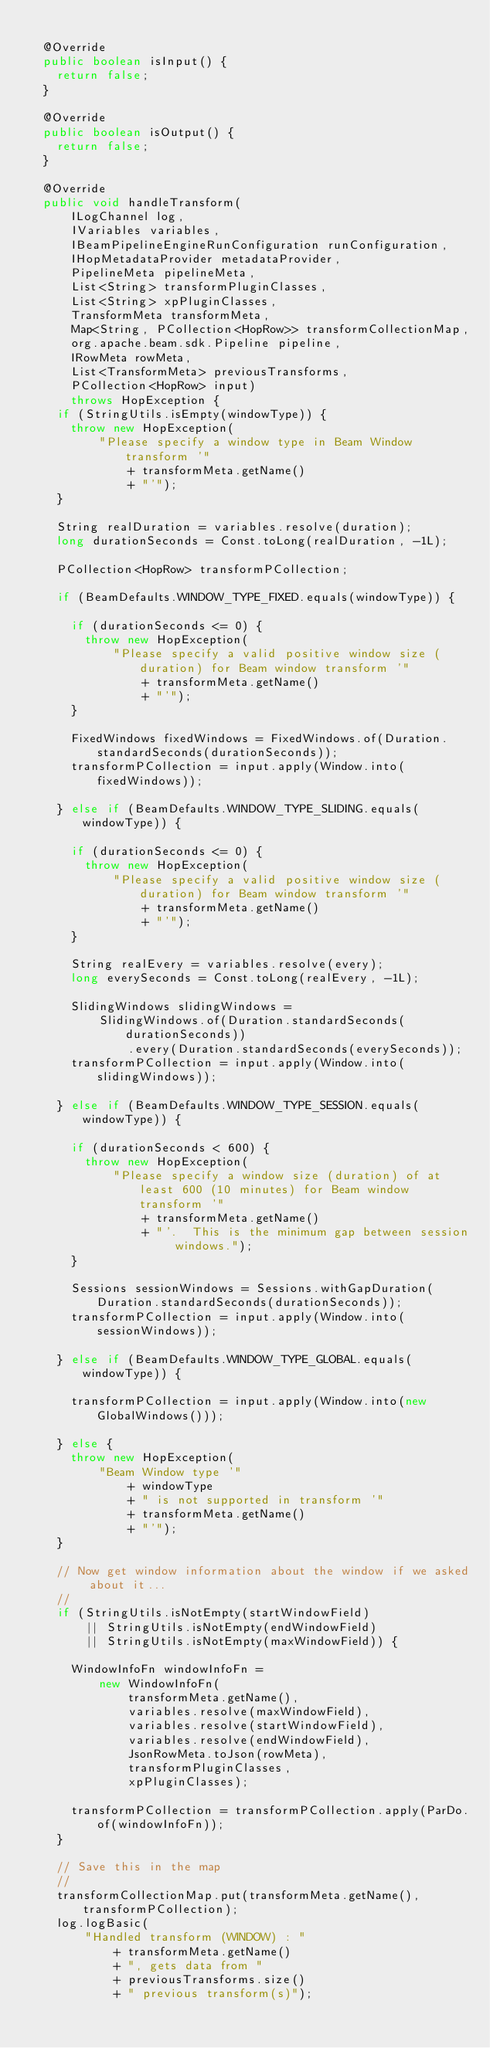<code> <loc_0><loc_0><loc_500><loc_500><_Java_>
  @Override
  public boolean isInput() {
    return false;
  }

  @Override
  public boolean isOutput() {
    return false;
  }

  @Override
  public void handleTransform(
      ILogChannel log,
      IVariables variables,
      IBeamPipelineEngineRunConfiguration runConfiguration,
      IHopMetadataProvider metadataProvider,
      PipelineMeta pipelineMeta,
      List<String> transformPluginClasses,
      List<String> xpPluginClasses,
      TransformMeta transformMeta,
      Map<String, PCollection<HopRow>> transformCollectionMap,
      org.apache.beam.sdk.Pipeline pipeline,
      IRowMeta rowMeta,
      List<TransformMeta> previousTransforms,
      PCollection<HopRow> input)
      throws HopException {
    if (StringUtils.isEmpty(windowType)) {
      throw new HopException(
          "Please specify a window type in Beam Window transform '"
              + transformMeta.getName()
              + "'");
    }

    String realDuration = variables.resolve(duration);
    long durationSeconds = Const.toLong(realDuration, -1L);

    PCollection<HopRow> transformPCollection;

    if (BeamDefaults.WINDOW_TYPE_FIXED.equals(windowType)) {

      if (durationSeconds <= 0) {
        throw new HopException(
            "Please specify a valid positive window size (duration) for Beam window transform '"
                + transformMeta.getName()
                + "'");
      }

      FixedWindows fixedWindows = FixedWindows.of(Duration.standardSeconds(durationSeconds));
      transformPCollection = input.apply(Window.into(fixedWindows));

    } else if (BeamDefaults.WINDOW_TYPE_SLIDING.equals(windowType)) {

      if (durationSeconds <= 0) {
        throw new HopException(
            "Please specify a valid positive window size (duration) for Beam window transform '"
                + transformMeta.getName()
                + "'");
      }

      String realEvery = variables.resolve(every);
      long everySeconds = Const.toLong(realEvery, -1L);

      SlidingWindows slidingWindows =
          SlidingWindows.of(Duration.standardSeconds(durationSeconds))
              .every(Duration.standardSeconds(everySeconds));
      transformPCollection = input.apply(Window.into(slidingWindows));

    } else if (BeamDefaults.WINDOW_TYPE_SESSION.equals(windowType)) {

      if (durationSeconds < 600) {
        throw new HopException(
            "Please specify a window size (duration) of at least 600 (10 minutes) for Beam window transform '"
                + transformMeta.getName()
                + "'.  This is the minimum gap between session windows.");
      }

      Sessions sessionWindows = Sessions.withGapDuration(Duration.standardSeconds(durationSeconds));
      transformPCollection = input.apply(Window.into(sessionWindows));

    } else if (BeamDefaults.WINDOW_TYPE_GLOBAL.equals(windowType)) {

      transformPCollection = input.apply(Window.into(new GlobalWindows()));

    } else {
      throw new HopException(
          "Beam Window type '"
              + windowType
              + " is not supported in transform '"
              + transformMeta.getName()
              + "'");
    }

    // Now get window information about the window if we asked about it...
    //
    if (StringUtils.isNotEmpty(startWindowField)
        || StringUtils.isNotEmpty(endWindowField)
        || StringUtils.isNotEmpty(maxWindowField)) {

      WindowInfoFn windowInfoFn =
          new WindowInfoFn(
              transformMeta.getName(),
              variables.resolve(maxWindowField),
              variables.resolve(startWindowField),
              variables.resolve(endWindowField),
              JsonRowMeta.toJson(rowMeta),
              transformPluginClasses,
              xpPluginClasses);

      transformPCollection = transformPCollection.apply(ParDo.of(windowInfoFn));
    }

    // Save this in the map
    //
    transformCollectionMap.put(transformMeta.getName(), transformPCollection);
    log.logBasic(
        "Handled transform (WINDOW) : "
            + transformMeta.getName()
            + ", gets data from "
            + previousTransforms.size()
            + " previous transform(s)");</code> 